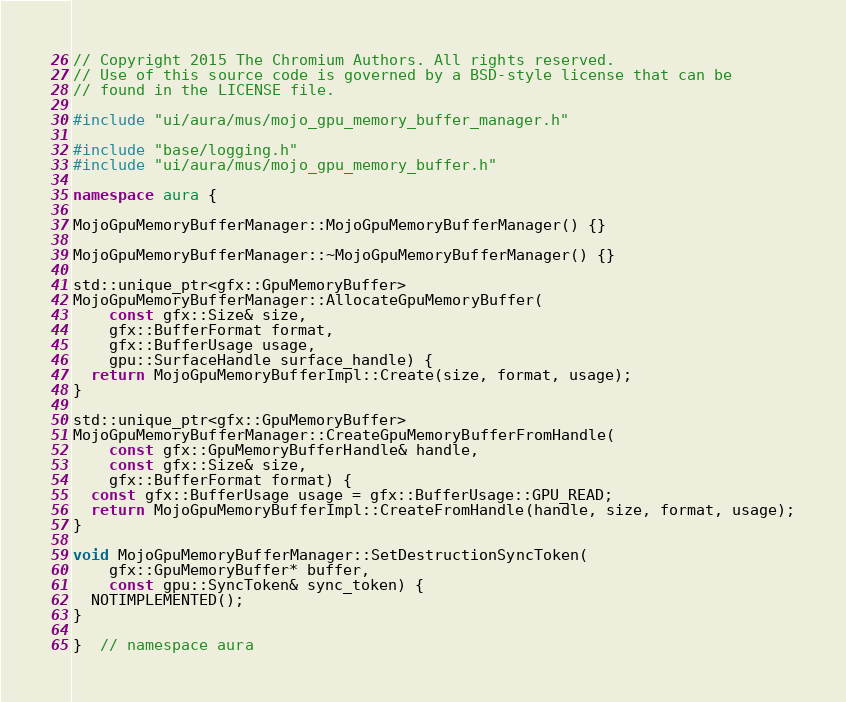<code> <loc_0><loc_0><loc_500><loc_500><_C++_>// Copyright 2015 The Chromium Authors. All rights reserved.
// Use of this source code is governed by a BSD-style license that can be
// found in the LICENSE file.

#include "ui/aura/mus/mojo_gpu_memory_buffer_manager.h"

#include "base/logging.h"
#include "ui/aura/mus/mojo_gpu_memory_buffer.h"

namespace aura {

MojoGpuMemoryBufferManager::MojoGpuMemoryBufferManager() {}

MojoGpuMemoryBufferManager::~MojoGpuMemoryBufferManager() {}

std::unique_ptr<gfx::GpuMemoryBuffer>
MojoGpuMemoryBufferManager::AllocateGpuMemoryBuffer(
    const gfx::Size& size,
    gfx::BufferFormat format,
    gfx::BufferUsage usage,
    gpu::SurfaceHandle surface_handle) {
  return MojoGpuMemoryBufferImpl::Create(size, format, usage);
}

std::unique_ptr<gfx::GpuMemoryBuffer>
MojoGpuMemoryBufferManager::CreateGpuMemoryBufferFromHandle(
    const gfx::GpuMemoryBufferHandle& handle,
    const gfx::Size& size,
    gfx::BufferFormat format) {
  const gfx::BufferUsage usage = gfx::BufferUsage::GPU_READ;
  return MojoGpuMemoryBufferImpl::CreateFromHandle(handle, size, format, usage);
}

void MojoGpuMemoryBufferManager::SetDestructionSyncToken(
    gfx::GpuMemoryBuffer* buffer,
    const gpu::SyncToken& sync_token) {
  NOTIMPLEMENTED();
}

}  // namespace aura
</code> 